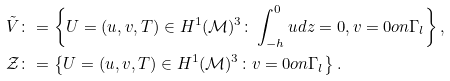Convert formula to latex. <formula><loc_0><loc_0><loc_500><loc_500>\tilde { V } & \colon = \left \{ U = ( u , v , T ) \in H ^ { 1 } ( \mathcal { M } ) ^ { 3 } \colon \int _ { - h } ^ { 0 } u d z = 0 , v = 0 o n \Gamma _ { l } \right \} , \\ \mathcal { Z } & \colon = \left \{ U = ( u , v , T ) \in H ^ { 1 } ( \mathcal { M } ) ^ { 3 } \colon v = 0 o n \Gamma _ { l } \right \} .</formula> 